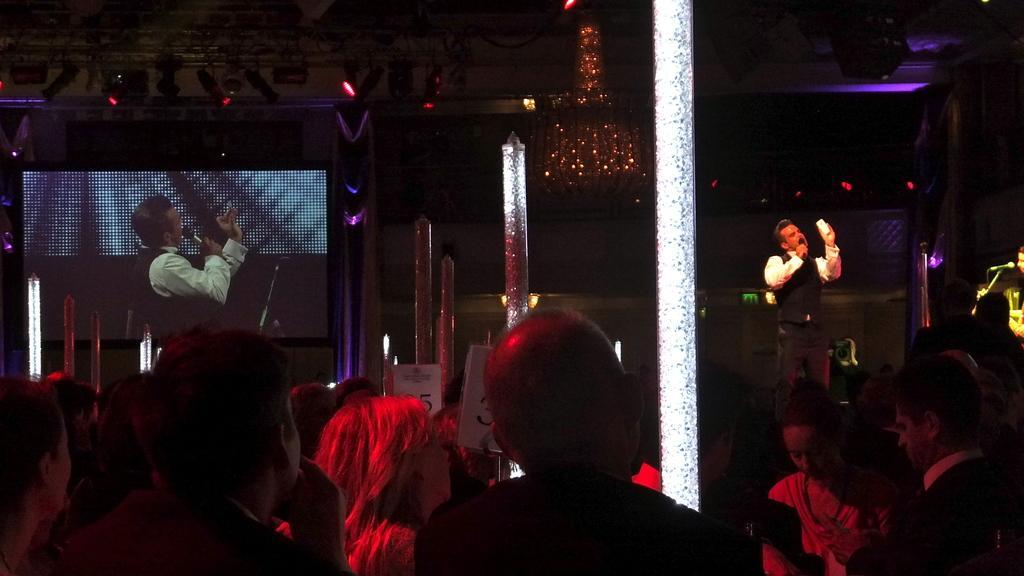In one or two sentences, can you explain what this image depicts? There are persons in a hall. In the background, there are two persons singing and standing on a stage, there are two white color pillars, there is a screen. And the background is dark in color. 